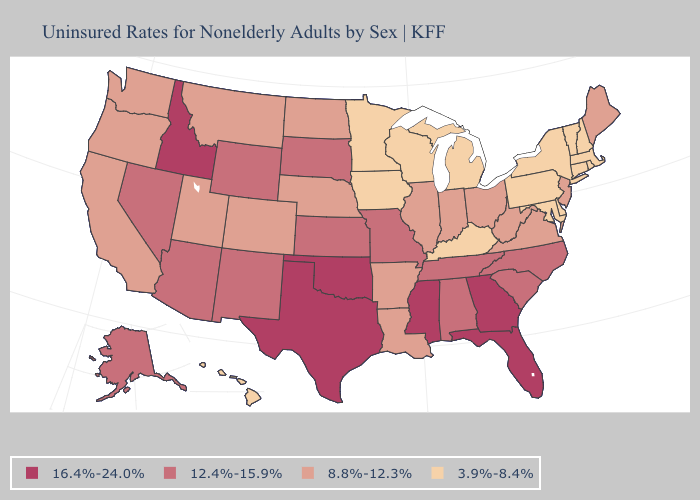Does the map have missing data?
Be succinct. No. What is the highest value in the USA?
Give a very brief answer. 16.4%-24.0%. What is the lowest value in the South?
Short answer required. 3.9%-8.4%. Does Maine have a lower value than West Virginia?
Give a very brief answer. No. Does Maine have a lower value than Georgia?
Write a very short answer. Yes. What is the lowest value in the West?
Be succinct. 3.9%-8.4%. Does Maine have the same value as Florida?
Short answer required. No. What is the highest value in the South ?
Give a very brief answer. 16.4%-24.0%. Does Hawaii have the lowest value in the West?
Concise answer only. Yes. Does Delaware have the highest value in the USA?
Answer briefly. No. What is the lowest value in the South?
Be succinct. 3.9%-8.4%. Which states have the lowest value in the USA?
Give a very brief answer. Connecticut, Delaware, Hawaii, Iowa, Kentucky, Maryland, Massachusetts, Michigan, Minnesota, New Hampshire, New York, Pennsylvania, Rhode Island, Vermont, Wisconsin. What is the value of Utah?
Be succinct. 8.8%-12.3%. What is the value of Maine?
Be succinct. 8.8%-12.3%. Is the legend a continuous bar?
Be succinct. No. 